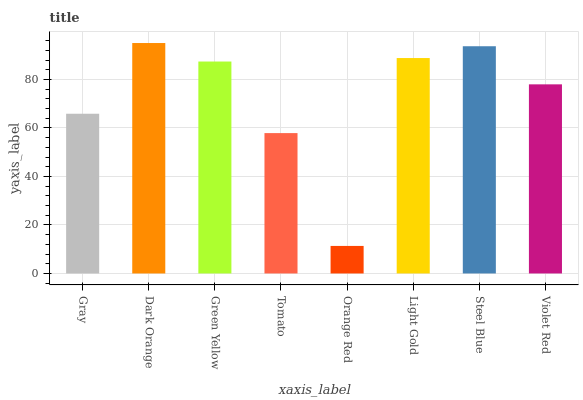Is Orange Red the minimum?
Answer yes or no. Yes. Is Dark Orange the maximum?
Answer yes or no. Yes. Is Green Yellow the minimum?
Answer yes or no. No. Is Green Yellow the maximum?
Answer yes or no. No. Is Dark Orange greater than Green Yellow?
Answer yes or no. Yes. Is Green Yellow less than Dark Orange?
Answer yes or no. Yes. Is Green Yellow greater than Dark Orange?
Answer yes or no. No. Is Dark Orange less than Green Yellow?
Answer yes or no. No. Is Green Yellow the high median?
Answer yes or no. Yes. Is Violet Red the low median?
Answer yes or no. Yes. Is Violet Red the high median?
Answer yes or no. No. Is Steel Blue the low median?
Answer yes or no. No. 